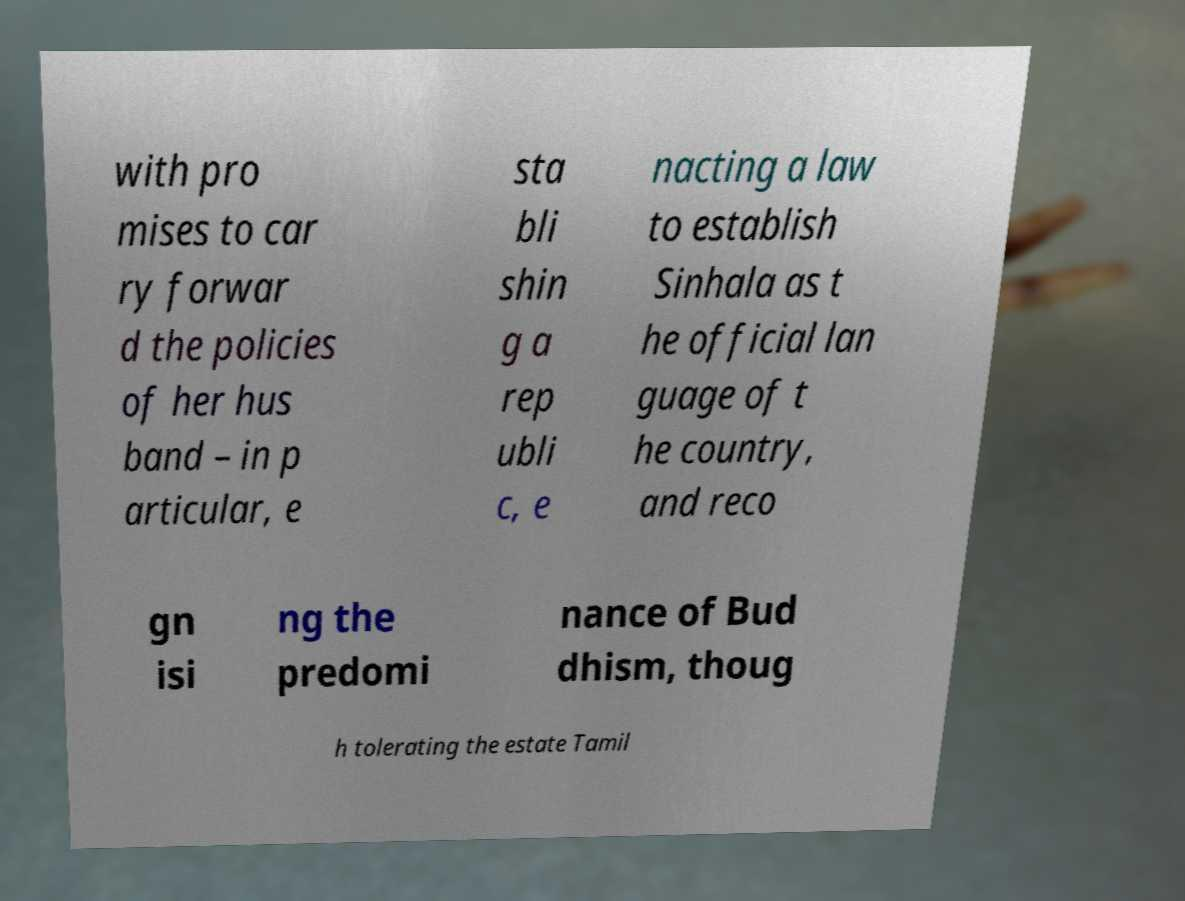Could you assist in decoding the text presented in this image and type it out clearly? with pro mises to car ry forwar d the policies of her hus band – in p articular, e sta bli shin g a rep ubli c, e nacting a law to establish Sinhala as t he official lan guage of t he country, and reco gn isi ng the predomi nance of Bud dhism, thoug h tolerating the estate Tamil 